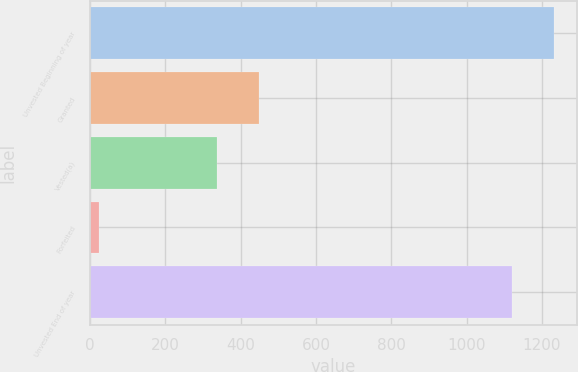Convert chart to OTSL. <chart><loc_0><loc_0><loc_500><loc_500><bar_chart><fcel>Unvested Beginning of year<fcel>Granted<fcel>Vested(a)<fcel>Forfeited<fcel>Unvested End of year<nl><fcel>1231<fcel>448<fcel>338<fcel>24<fcel>1121<nl></chart> 